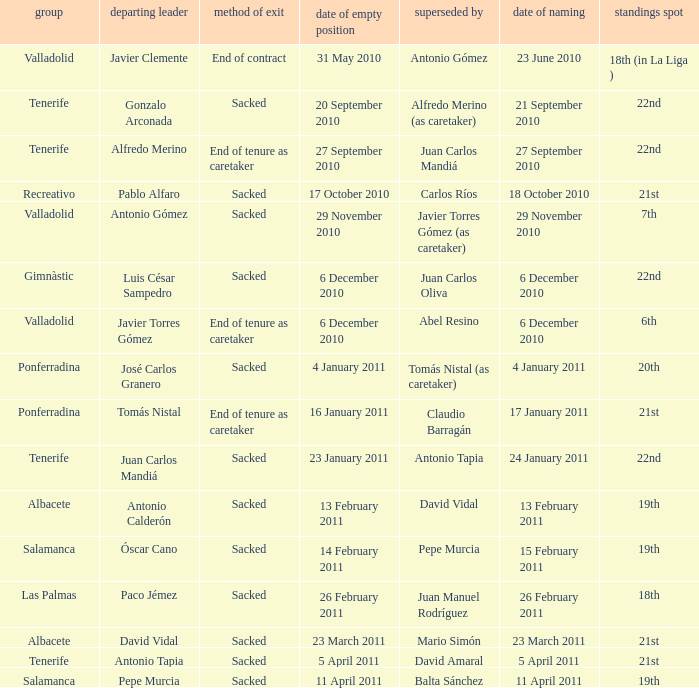What was the manner of departure for the appointment date of 21 september 2010 Sacked. 